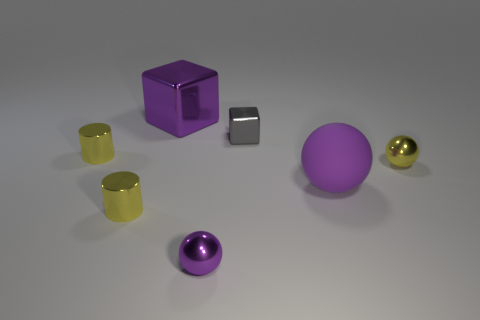There is a ball that is the same color as the matte thing; what is its material?
Ensure brevity in your answer.  Metal. What number of tiny cyan shiny cylinders are there?
Give a very brief answer. 0. Is the large block made of the same material as the small sphere that is behind the small purple metal sphere?
Provide a succinct answer. Yes. Do the metal sphere that is to the left of the big matte thing and the large ball have the same color?
Your answer should be very brief. Yes. The object that is both right of the small block and behind the large matte sphere is made of what material?
Give a very brief answer. Metal. How big is the purple metal ball?
Provide a short and direct response. Small. Is the color of the big cube the same as the metallic object to the right of the big purple ball?
Offer a very short reply. No. What number of other things are there of the same color as the big sphere?
Keep it short and to the point. 2. There is a cube to the left of the small cube; is it the same size as the matte sphere in front of the purple shiny block?
Your answer should be compact. Yes. There is a rubber object to the right of the gray shiny block; what color is it?
Provide a short and direct response. Purple. 